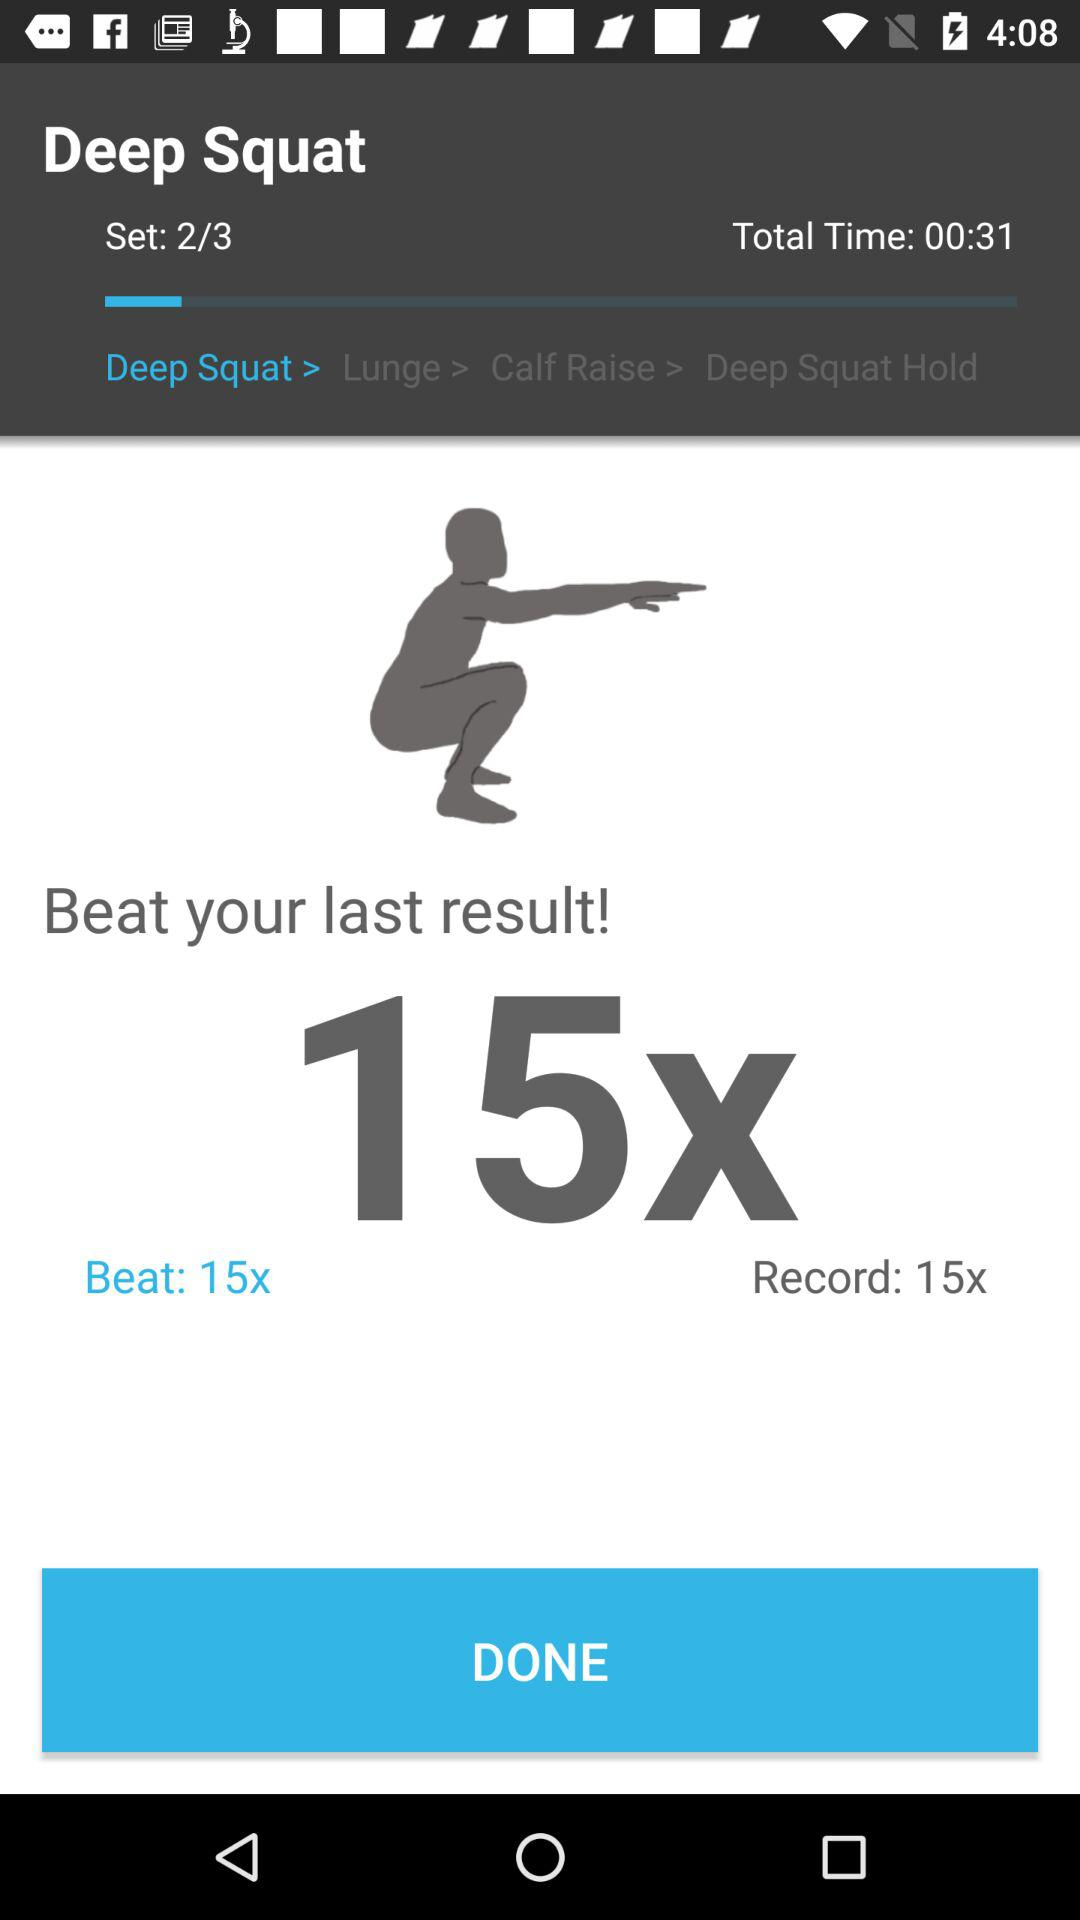What is the set number? The set number is 2. 